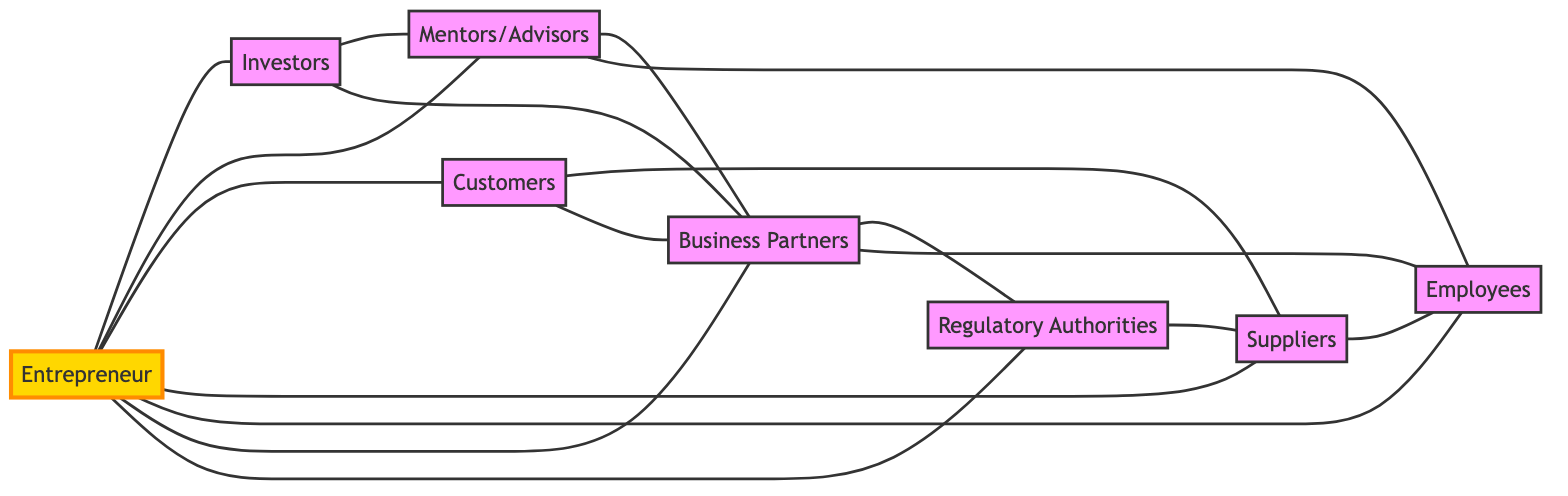What is the total number of nodes in the graph? There are 8 distinct entities represented in the graph: Entrepreneur, Investors, Mentors/Advisors, Customers, Suppliers, Employees, Business Partners, and Regulatory Authorities. Therefore, counting all these unique nodes gives us a total of 8.
Answer: 8 Which stakeholders does the Entrepreneur connect to? The Entrepreneur connects directly to Investors, Mentors/Advisors, Customers, Suppliers, Employees, Business Partners, and Regulatory Authorities. Listing these, we find 7 connections.
Answer: 7 Who are the direct connections of the Suppliers? The Suppliers have direct connections to Customers, Employees, and Regulatory Authorities as per the edges in the graph. So, together, these three represent the direct stakeholders related to Suppliers.
Answer: Customers, Employees, Regulatory Authorities Is there a direct connection between Investors and Employees? There is no direct edge connecting Investors and Employees. Evaluating the connections listed shows that no line is drawn between these two entities directly.
Answer: No What is the degree of the Business Partners? The degree of Business Partners is calculated by counting its direct connections: it connects to Entrepreneur, Investors, Mentors/Advisors, Customers, Employees, and Regulatory Authorities, amounting to 6 edges in total.
Answer: 6 How many connections does Customers have in total? Customers are directly connected to Suppliers, Business Partners, and the Entrepreneur. Counting these edges results in a total of 3 connections for the Customers node.
Answer: 3 Which stakeholder has the most connections? By counting the connections, we find that the Entrepreneur has 7 direct connections, which is the highest compared to any other stakeholder in the graph.
Answer: Entrepreneur Are Mentors/Advisors and Regulatory Authorities directly connected? Upon examining the connections in the graph, there is no edge drawn between Mentors/Advisors and Regulatory Authorities, indicating that they are not directly connected to each other.
Answer: No What number of relationships does the Regulatory Authorities maintain? Regulatory Authorities are directly connected to Business Partners and Suppliers which gives a total of 2 direct relationships.
Answer: 2 